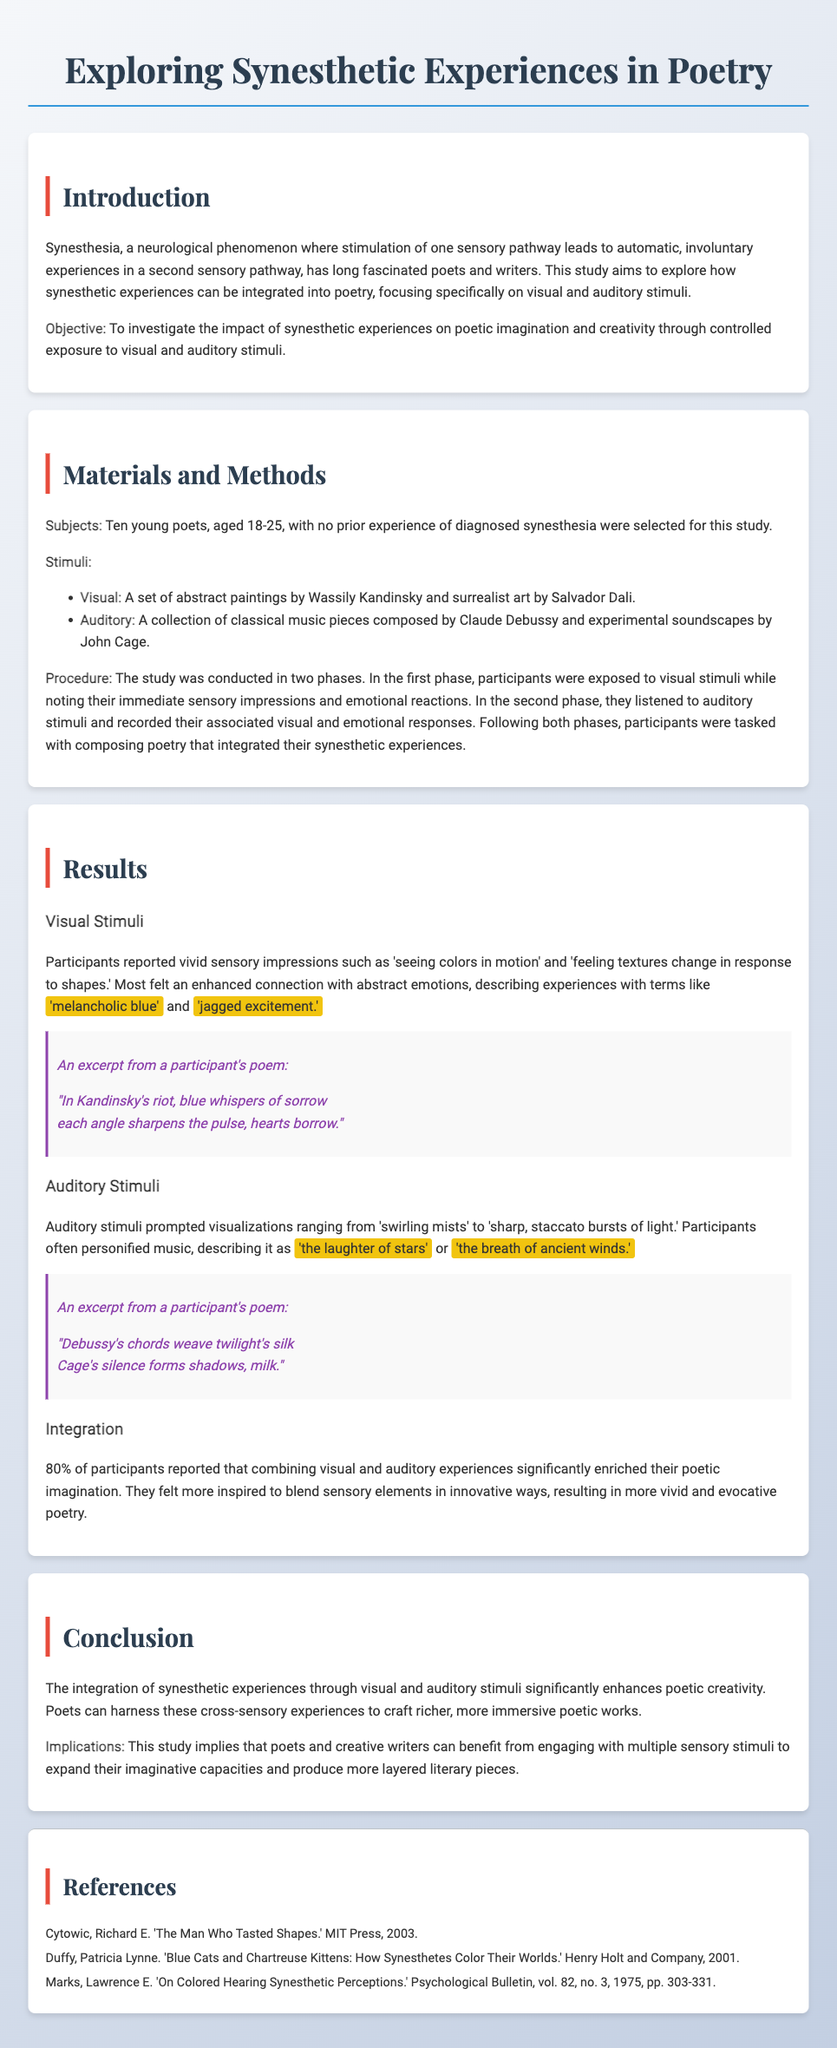what is the age range of subjects in the study? The age range of the selected subjects for the study is provided in the document as 18-25.
Answer: 18-25 who is the first author mentioned in the references? The first author mentioned in the references in the document is Richard E. Cytowic.
Answer: Richard E. Cytowic what type of art was used as visual stimuli? The document states that abstract paintings by Wassily Kandinsky and surrealist art by Salvador Dali were used as visual stimuli.
Answer: abstract paintings by Wassily Kandinsky and surrealist art by Salvador Dali how many participants reported enhanced poetic imagination? According to the findings discussed in the results section, 80% of participants reported enhanced poetic imagination.
Answer: 80% what were the auditory stimuli used in the study? The auditory stimuli used in the study include classical music pieces composed by Claude Debussy and experimental soundscapes by John Cage.
Answer: classical music pieces composed by Claude Debussy and experimental soundscapes by John Cage what was the conclusion about synesthetic experiences? The conclusion in the document provides an assertion that synesthetic experiences significantly enhance poetic creativity.
Answer: significantly enhance poetic creativity how many phases were there in the study's procedure? The study's procedure consisted of two phases as mentioned in the methods section.
Answer: two phases what style is the excerpt from the participant's poem? The excerpt from the participant's poem is written in an italic style as denoted in the document.
Answer: italic 